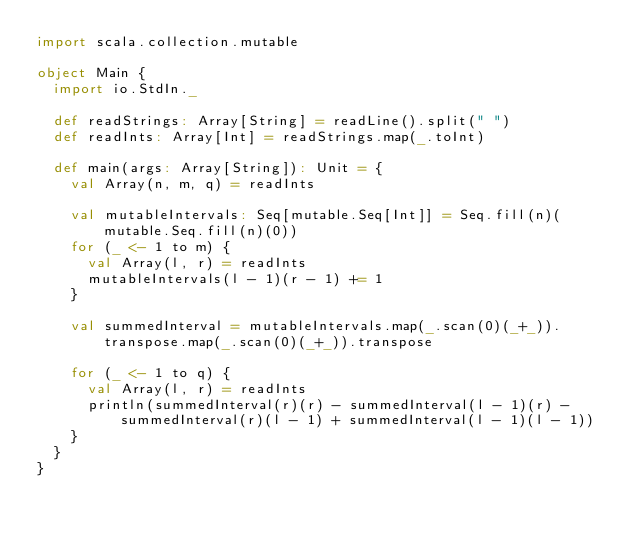Convert code to text. <code><loc_0><loc_0><loc_500><loc_500><_Scala_>import scala.collection.mutable

object Main {
  import io.StdIn._

  def readStrings: Array[String] = readLine().split(" ")
  def readInts: Array[Int] = readStrings.map(_.toInt)

  def main(args: Array[String]): Unit = {
    val Array(n, m, q) = readInts

    val mutableIntervals: Seq[mutable.Seq[Int]] = Seq.fill(n)(mutable.Seq.fill(n)(0))
    for (_ <- 1 to m) {
      val Array(l, r) = readInts
      mutableIntervals(l - 1)(r - 1) += 1
    }

    val summedInterval = mutableIntervals.map(_.scan(0)(_+_)).transpose.map(_.scan(0)(_+_)).transpose

    for (_ <- 1 to q) {
      val Array(l, r) = readInts
      println(summedInterval(r)(r) - summedInterval(l - 1)(r) - summedInterval(r)(l - 1) + summedInterval(l - 1)(l - 1))
    }
  }
}
</code> 